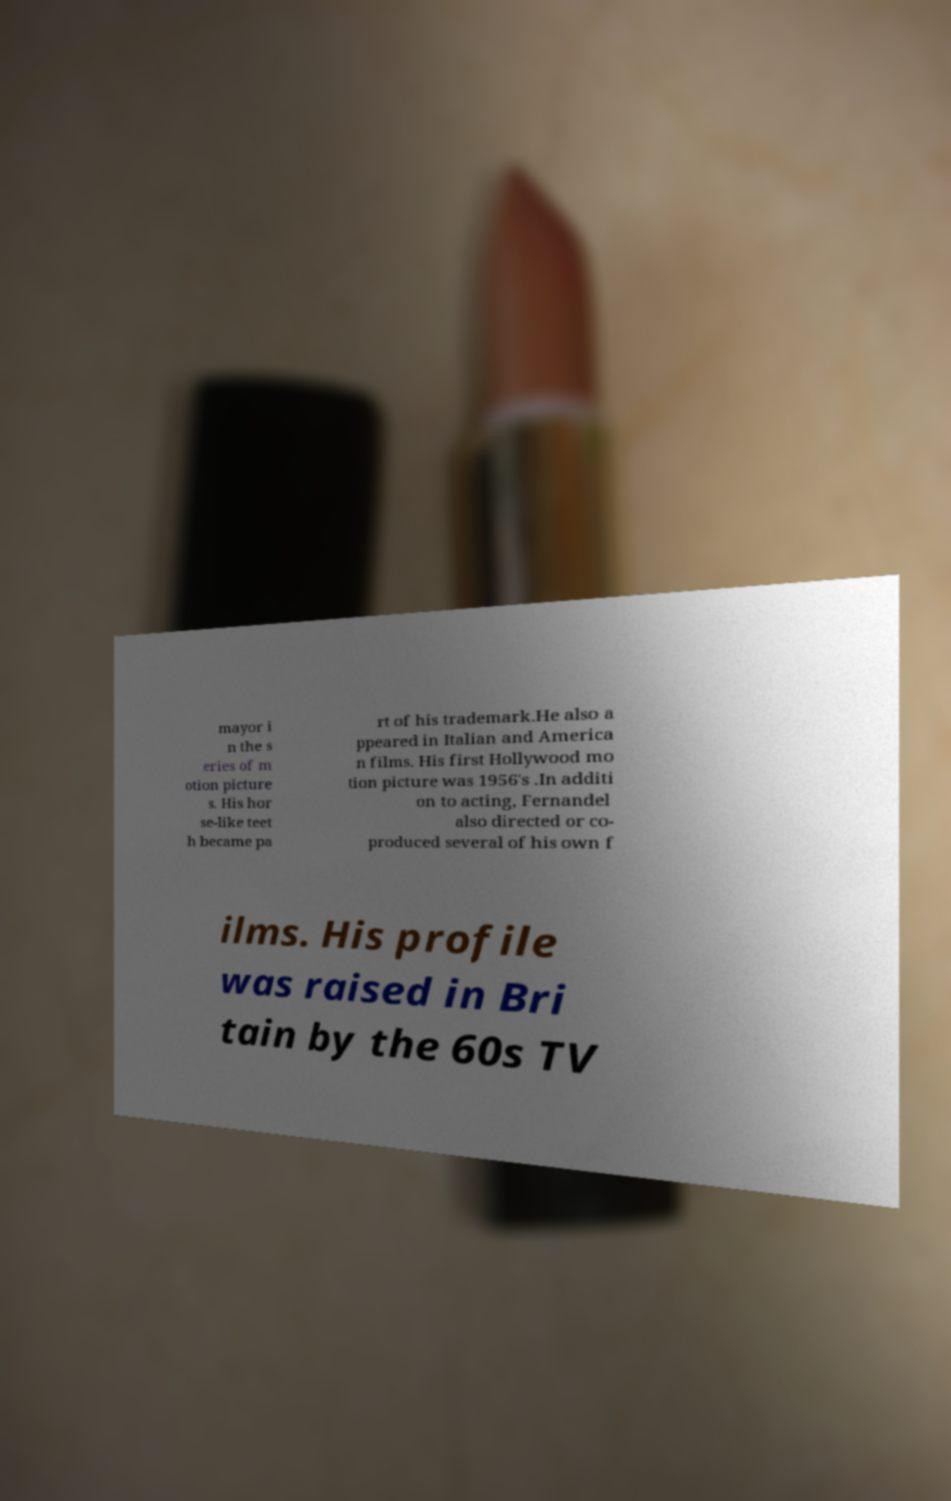What messages or text are displayed in this image? I need them in a readable, typed format. mayor i n the s eries of m otion picture s. His hor se-like teet h became pa rt of his trademark.He also a ppeared in Italian and America n films. His first Hollywood mo tion picture was 1956's .In additi on to acting, Fernandel also directed or co- produced several of his own f ilms. His profile was raised in Bri tain by the 60s TV 